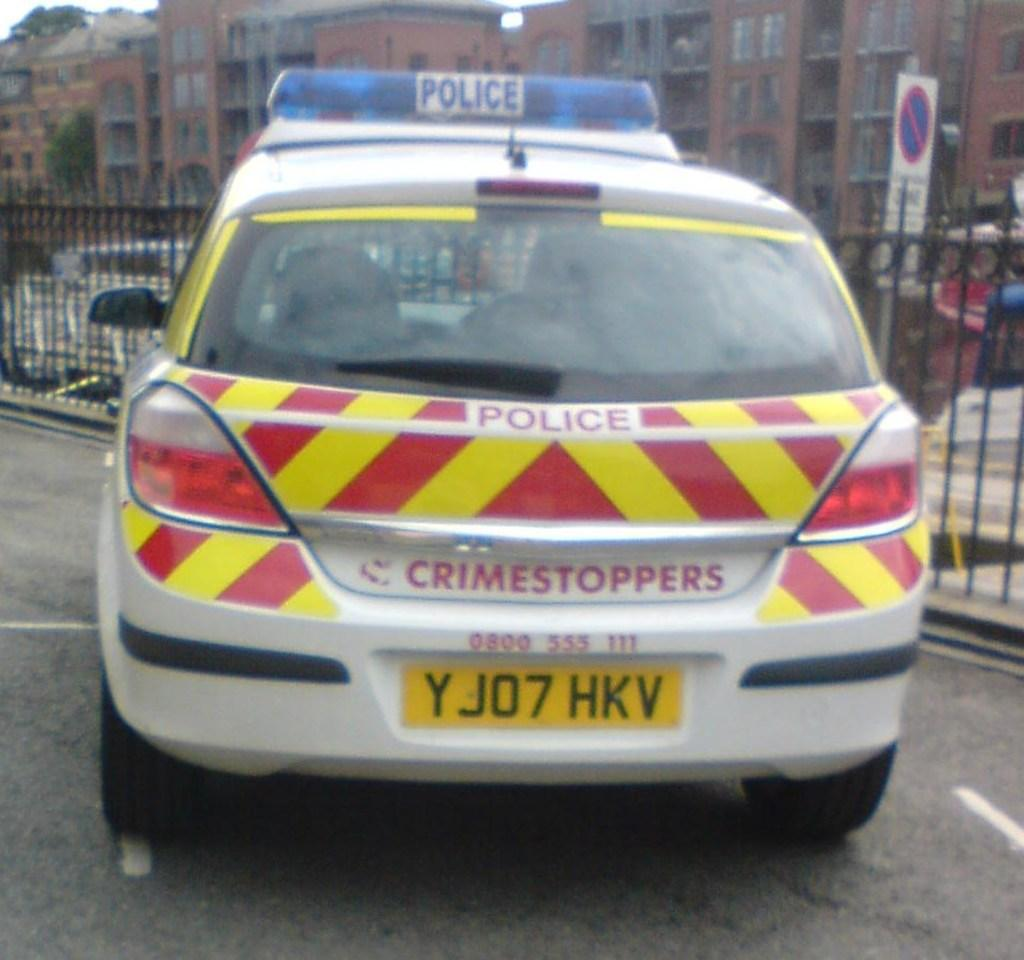What type of vehicle is in the image? There is a police car in the image. Where is the police car located? The police car is parked on the road. What is near the police car? The police car is beside iron bars. What can be seen in the distance in the image? There are buildings visible in the background of the image. How many toes are visible on the police officer's foot in the image? There are no visible toes or police officer's foot in the image; it only shows a parked police car beside iron bars. 